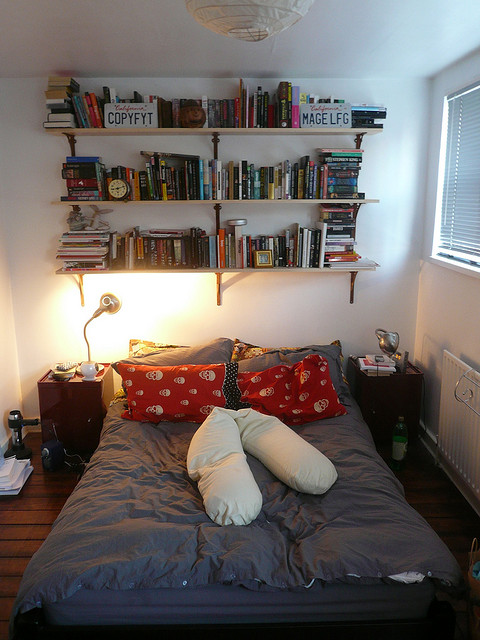Describe a realistic scenario where someone finds peace in this room after a long day. After a grueling day at work, Sarah returns home to her cozy sanctuary. The moment she steps into the room, she feels an immediate sense of relief. The soft, warm glow from the bedside lamp casts a comforting light over the room. Sarah changes into her comfortable pajamas, brews a cup of herbal tea, and picks out a new novel from the bookshelf. As she settles onto the bed with the red and white pillows, the stresses of the day melt away. Engrossed in the world of her book, she finds solace and tranquility, enveloped by the serene ambiance of her personal reading haven. 